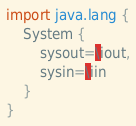<code> <loc_0><loc_0><loc_500><loc_500><_Ceylon_>import java.lang {
    System {
        sysout=\iout,
        sysin=\iin
    }
}
</code> 